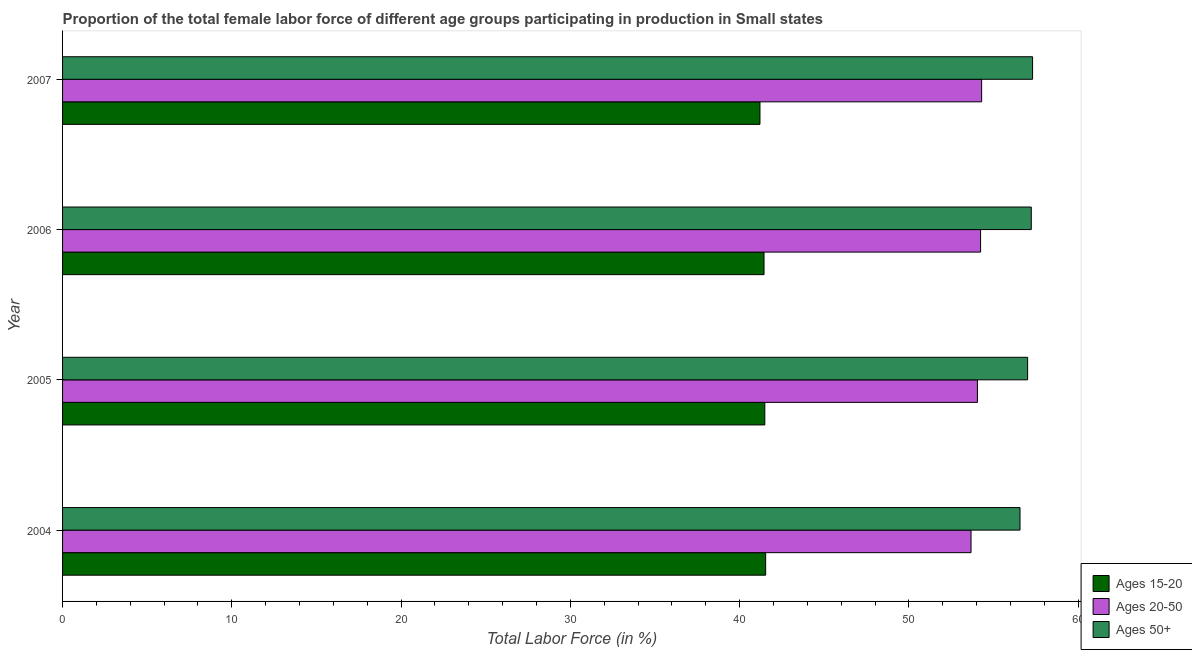How many different coloured bars are there?
Your answer should be very brief. 3. How many groups of bars are there?
Ensure brevity in your answer.  4. How many bars are there on the 4th tick from the bottom?
Your answer should be very brief. 3. What is the label of the 1st group of bars from the top?
Provide a succinct answer. 2007. In how many cases, is the number of bars for a given year not equal to the number of legend labels?
Ensure brevity in your answer.  0. What is the percentage of female labor force above age 50 in 2006?
Offer a terse response. 57.23. Across all years, what is the maximum percentage of female labor force within the age group 20-50?
Your response must be concise. 54.29. Across all years, what is the minimum percentage of female labor force within the age group 15-20?
Provide a short and direct response. 41.2. In which year was the percentage of female labor force above age 50 maximum?
Provide a short and direct response. 2007. What is the total percentage of female labor force above age 50 in the graph?
Provide a succinct answer. 228.11. What is the difference between the percentage of female labor force above age 50 in 2006 and that in 2007?
Ensure brevity in your answer.  -0.08. What is the difference between the percentage of female labor force above age 50 in 2005 and the percentage of female labor force within the age group 15-20 in 2004?
Your answer should be compact. 15.48. What is the average percentage of female labor force within the age group 20-50 per year?
Offer a very short reply. 54.06. In the year 2007, what is the difference between the percentage of female labor force within the age group 20-50 and percentage of female labor force within the age group 15-20?
Keep it short and to the point. 13.1. What is the ratio of the percentage of female labor force within the age group 15-20 in 2005 to that in 2007?
Make the answer very short. 1.01. What is the difference between the highest and the second highest percentage of female labor force within the age group 15-20?
Provide a short and direct response. 0.05. What is the difference between the highest and the lowest percentage of female labor force above age 50?
Make the answer very short. 0.74. Is the sum of the percentage of female labor force within the age group 20-50 in 2004 and 2005 greater than the maximum percentage of female labor force above age 50 across all years?
Give a very brief answer. Yes. What does the 1st bar from the top in 2006 represents?
Your response must be concise. Ages 50+. What does the 3rd bar from the bottom in 2007 represents?
Provide a short and direct response. Ages 50+. How many years are there in the graph?
Offer a terse response. 4. Are the values on the major ticks of X-axis written in scientific E-notation?
Your response must be concise. No. Where does the legend appear in the graph?
Keep it short and to the point. Bottom right. How many legend labels are there?
Provide a succinct answer. 3. What is the title of the graph?
Keep it short and to the point. Proportion of the total female labor force of different age groups participating in production in Small states. Does "Labor Tax" appear as one of the legend labels in the graph?
Offer a terse response. No. What is the label or title of the X-axis?
Provide a succinct answer. Total Labor Force (in %). What is the Total Labor Force (in %) of Ages 15-20 in 2004?
Provide a short and direct response. 41.54. What is the Total Labor Force (in %) in Ages 20-50 in 2004?
Your answer should be compact. 53.67. What is the Total Labor Force (in %) of Ages 50+ in 2004?
Your answer should be very brief. 56.56. What is the Total Labor Force (in %) of Ages 15-20 in 2005?
Ensure brevity in your answer.  41.49. What is the Total Labor Force (in %) of Ages 20-50 in 2005?
Make the answer very short. 54.04. What is the Total Labor Force (in %) of Ages 50+ in 2005?
Provide a short and direct response. 57.01. What is the Total Labor Force (in %) of Ages 15-20 in 2006?
Make the answer very short. 41.44. What is the Total Labor Force (in %) of Ages 20-50 in 2006?
Your response must be concise. 54.23. What is the Total Labor Force (in %) of Ages 50+ in 2006?
Your answer should be very brief. 57.23. What is the Total Labor Force (in %) in Ages 15-20 in 2007?
Ensure brevity in your answer.  41.2. What is the Total Labor Force (in %) in Ages 20-50 in 2007?
Offer a very short reply. 54.29. What is the Total Labor Force (in %) in Ages 50+ in 2007?
Provide a short and direct response. 57.3. Across all years, what is the maximum Total Labor Force (in %) of Ages 15-20?
Keep it short and to the point. 41.54. Across all years, what is the maximum Total Labor Force (in %) of Ages 20-50?
Provide a succinct answer. 54.29. Across all years, what is the maximum Total Labor Force (in %) in Ages 50+?
Offer a terse response. 57.3. Across all years, what is the minimum Total Labor Force (in %) of Ages 15-20?
Your answer should be compact. 41.2. Across all years, what is the minimum Total Labor Force (in %) of Ages 20-50?
Ensure brevity in your answer.  53.67. Across all years, what is the minimum Total Labor Force (in %) in Ages 50+?
Make the answer very short. 56.56. What is the total Total Labor Force (in %) of Ages 15-20 in the graph?
Ensure brevity in your answer.  165.66. What is the total Total Labor Force (in %) in Ages 20-50 in the graph?
Offer a very short reply. 216.24. What is the total Total Labor Force (in %) in Ages 50+ in the graph?
Provide a short and direct response. 228.11. What is the difference between the Total Labor Force (in %) of Ages 15-20 in 2004 and that in 2005?
Your answer should be very brief. 0.05. What is the difference between the Total Labor Force (in %) of Ages 20-50 in 2004 and that in 2005?
Provide a succinct answer. -0.38. What is the difference between the Total Labor Force (in %) in Ages 50+ in 2004 and that in 2005?
Offer a very short reply. -0.45. What is the difference between the Total Labor Force (in %) of Ages 15-20 in 2004 and that in 2006?
Your answer should be very brief. 0.1. What is the difference between the Total Labor Force (in %) of Ages 20-50 in 2004 and that in 2006?
Provide a short and direct response. -0.56. What is the difference between the Total Labor Force (in %) of Ages 50+ in 2004 and that in 2006?
Ensure brevity in your answer.  -0.67. What is the difference between the Total Labor Force (in %) of Ages 15-20 in 2004 and that in 2007?
Offer a very short reply. 0.34. What is the difference between the Total Labor Force (in %) of Ages 20-50 in 2004 and that in 2007?
Provide a short and direct response. -0.63. What is the difference between the Total Labor Force (in %) in Ages 50+ in 2004 and that in 2007?
Your response must be concise. -0.74. What is the difference between the Total Labor Force (in %) of Ages 15-20 in 2005 and that in 2006?
Your answer should be very brief. 0.05. What is the difference between the Total Labor Force (in %) of Ages 20-50 in 2005 and that in 2006?
Your answer should be compact. -0.19. What is the difference between the Total Labor Force (in %) of Ages 50+ in 2005 and that in 2006?
Your answer should be compact. -0.22. What is the difference between the Total Labor Force (in %) in Ages 15-20 in 2005 and that in 2007?
Provide a succinct answer. 0.29. What is the difference between the Total Labor Force (in %) in Ages 20-50 in 2005 and that in 2007?
Your response must be concise. -0.25. What is the difference between the Total Labor Force (in %) of Ages 50+ in 2005 and that in 2007?
Ensure brevity in your answer.  -0.29. What is the difference between the Total Labor Force (in %) in Ages 15-20 in 2006 and that in 2007?
Your response must be concise. 0.24. What is the difference between the Total Labor Force (in %) of Ages 20-50 in 2006 and that in 2007?
Give a very brief answer. -0.06. What is the difference between the Total Labor Force (in %) in Ages 50+ in 2006 and that in 2007?
Offer a terse response. -0.08. What is the difference between the Total Labor Force (in %) of Ages 15-20 in 2004 and the Total Labor Force (in %) of Ages 20-50 in 2005?
Make the answer very short. -12.51. What is the difference between the Total Labor Force (in %) of Ages 15-20 in 2004 and the Total Labor Force (in %) of Ages 50+ in 2005?
Your answer should be very brief. -15.48. What is the difference between the Total Labor Force (in %) of Ages 20-50 in 2004 and the Total Labor Force (in %) of Ages 50+ in 2005?
Keep it short and to the point. -3.34. What is the difference between the Total Labor Force (in %) in Ages 15-20 in 2004 and the Total Labor Force (in %) in Ages 20-50 in 2006?
Provide a succinct answer. -12.7. What is the difference between the Total Labor Force (in %) of Ages 15-20 in 2004 and the Total Labor Force (in %) of Ages 50+ in 2006?
Provide a succinct answer. -15.69. What is the difference between the Total Labor Force (in %) in Ages 20-50 in 2004 and the Total Labor Force (in %) in Ages 50+ in 2006?
Your response must be concise. -3.56. What is the difference between the Total Labor Force (in %) of Ages 15-20 in 2004 and the Total Labor Force (in %) of Ages 20-50 in 2007?
Offer a very short reply. -12.76. What is the difference between the Total Labor Force (in %) of Ages 15-20 in 2004 and the Total Labor Force (in %) of Ages 50+ in 2007?
Provide a succinct answer. -15.77. What is the difference between the Total Labor Force (in %) of Ages 20-50 in 2004 and the Total Labor Force (in %) of Ages 50+ in 2007?
Provide a succinct answer. -3.64. What is the difference between the Total Labor Force (in %) of Ages 15-20 in 2005 and the Total Labor Force (in %) of Ages 20-50 in 2006?
Give a very brief answer. -12.75. What is the difference between the Total Labor Force (in %) of Ages 15-20 in 2005 and the Total Labor Force (in %) of Ages 50+ in 2006?
Your answer should be very brief. -15.74. What is the difference between the Total Labor Force (in %) in Ages 20-50 in 2005 and the Total Labor Force (in %) in Ages 50+ in 2006?
Your answer should be compact. -3.18. What is the difference between the Total Labor Force (in %) in Ages 15-20 in 2005 and the Total Labor Force (in %) in Ages 20-50 in 2007?
Your response must be concise. -12.81. What is the difference between the Total Labor Force (in %) in Ages 15-20 in 2005 and the Total Labor Force (in %) in Ages 50+ in 2007?
Make the answer very short. -15.82. What is the difference between the Total Labor Force (in %) of Ages 20-50 in 2005 and the Total Labor Force (in %) of Ages 50+ in 2007?
Keep it short and to the point. -3.26. What is the difference between the Total Labor Force (in %) of Ages 15-20 in 2006 and the Total Labor Force (in %) of Ages 20-50 in 2007?
Give a very brief answer. -12.85. What is the difference between the Total Labor Force (in %) in Ages 15-20 in 2006 and the Total Labor Force (in %) in Ages 50+ in 2007?
Your answer should be very brief. -15.86. What is the difference between the Total Labor Force (in %) of Ages 20-50 in 2006 and the Total Labor Force (in %) of Ages 50+ in 2007?
Make the answer very short. -3.07. What is the average Total Labor Force (in %) in Ages 15-20 per year?
Keep it short and to the point. 41.42. What is the average Total Labor Force (in %) of Ages 20-50 per year?
Your response must be concise. 54.06. What is the average Total Labor Force (in %) in Ages 50+ per year?
Provide a succinct answer. 57.03. In the year 2004, what is the difference between the Total Labor Force (in %) of Ages 15-20 and Total Labor Force (in %) of Ages 20-50?
Make the answer very short. -12.13. In the year 2004, what is the difference between the Total Labor Force (in %) in Ages 15-20 and Total Labor Force (in %) in Ages 50+?
Ensure brevity in your answer.  -15.03. In the year 2004, what is the difference between the Total Labor Force (in %) of Ages 20-50 and Total Labor Force (in %) of Ages 50+?
Make the answer very short. -2.89. In the year 2005, what is the difference between the Total Labor Force (in %) of Ages 15-20 and Total Labor Force (in %) of Ages 20-50?
Make the answer very short. -12.56. In the year 2005, what is the difference between the Total Labor Force (in %) of Ages 15-20 and Total Labor Force (in %) of Ages 50+?
Keep it short and to the point. -15.53. In the year 2005, what is the difference between the Total Labor Force (in %) in Ages 20-50 and Total Labor Force (in %) in Ages 50+?
Ensure brevity in your answer.  -2.97. In the year 2006, what is the difference between the Total Labor Force (in %) in Ages 15-20 and Total Labor Force (in %) in Ages 20-50?
Provide a succinct answer. -12.79. In the year 2006, what is the difference between the Total Labor Force (in %) in Ages 15-20 and Total Labor Force (in %) in Ages 50+?
Keep it short and to the point. -15.79. In the year 2006, what is the difference between the Total Labor Force (in %) in Ages 20-50 and Total Labor Force (in %) in Ages 50+?
Your answer should be very brief. -3. In the year 2007, what is the difference between the Total Labor Force (in %) of Ages 15-20 and Total Labor Force (in %) of Ages 20-50?
Your answer should be very brief. -13.09. In the year 2007, what is the difference between the Total Labor Force (in %) of Ages 15-20 and Total Labor Force (in %) of Ages 50+?
Make the answer very short. -16.1. In the year 2007, what is the difference between the Total Labor Force (in %) in Ages 20-50 and Total Labor Force (in %) in Ages 50+?
Provide a short and direct response. -3.01. What is the ratio of the Total Labor Force (in %) of Ages 20-50 in 2004 to that in 2005?
Your answer should be very brief. 0.99. What is the ratio of the Total Labor Force (in %) in Ages 20-50 in 2004 to that in 2006?
Provide a succinct answer. 0.99. What is the ratio of the Total Labor Force (in %) in Ages 50+ in 2004 to that in 2006?
Your answer should be compact. 0.99. What is the ratio of the Total Labor Force (in %) in Ages 15-20 in 2004 to that in 2007?
Give a very brief answer. 1.01. What is the ratio of the Total Labor Force (in %) of Ages 20-50 in 2004 to that in 2007?
Offer a terse response. 0.99. What is the ratio of the Total Labor Force (in %) in Ages 15-20 in 2005 to that in 2006?
Ensure brevity in your answer.  1. What is the ratio of the Total Labor Force (in %) of Ages 20-50 in 2005 to that in 2006?
Offer a very short reply. 1. What is the ratio of the Total Labor Force (in %) in Ages 50+ in 2005 to that in 2006?
Give a very brief answer. 1. What is the ratio of the Total Labor Force (in %) of Ages 20-50 in 2005 to that in 2007?
Provide a short and direct response. 1. What is the ratio of the Total Labor Force (in %) of Ages 50+ in 2005 to that in 2007?
Your answer should be very brief. 0.99. What is the ratio of the Total Labor Force (in %) in Ages 15-20 in 2006 to that in 2007?
Make the answer very short. 1.01. What is the ratio of the Total Labor Force (in %) of Ages 20-50 in 2006 to that in 2007?
Ensure brevity in your answer.  1. What is the difference between the highest and the second highest Total Labor Force (in %) in Ages 15-20?
Provide a short and direct response. 0.05. What is the difference between the highest and the second highest Total Labor Force (in %) of Ages 20-50?
Your response must be concise. 0.06. What is the difference between the highest and the second highest Total Labor Force (in %) in Ages 50+?
Your answer should be compact. 0.08. What is the difference between the highest and the lowest Total Labor Force (in %) of Ages 15-20?
Keep it short and to the point. 0.34. What is the difference between the highest and the lowest Total Labor Force (in %) in Ages 20-50?
Your answer should be very brief. 0.63. What is the difference between the highest and the lowest Total Labor Force (in %) in Ages 50+?
Offer a terse response. 0.74. 